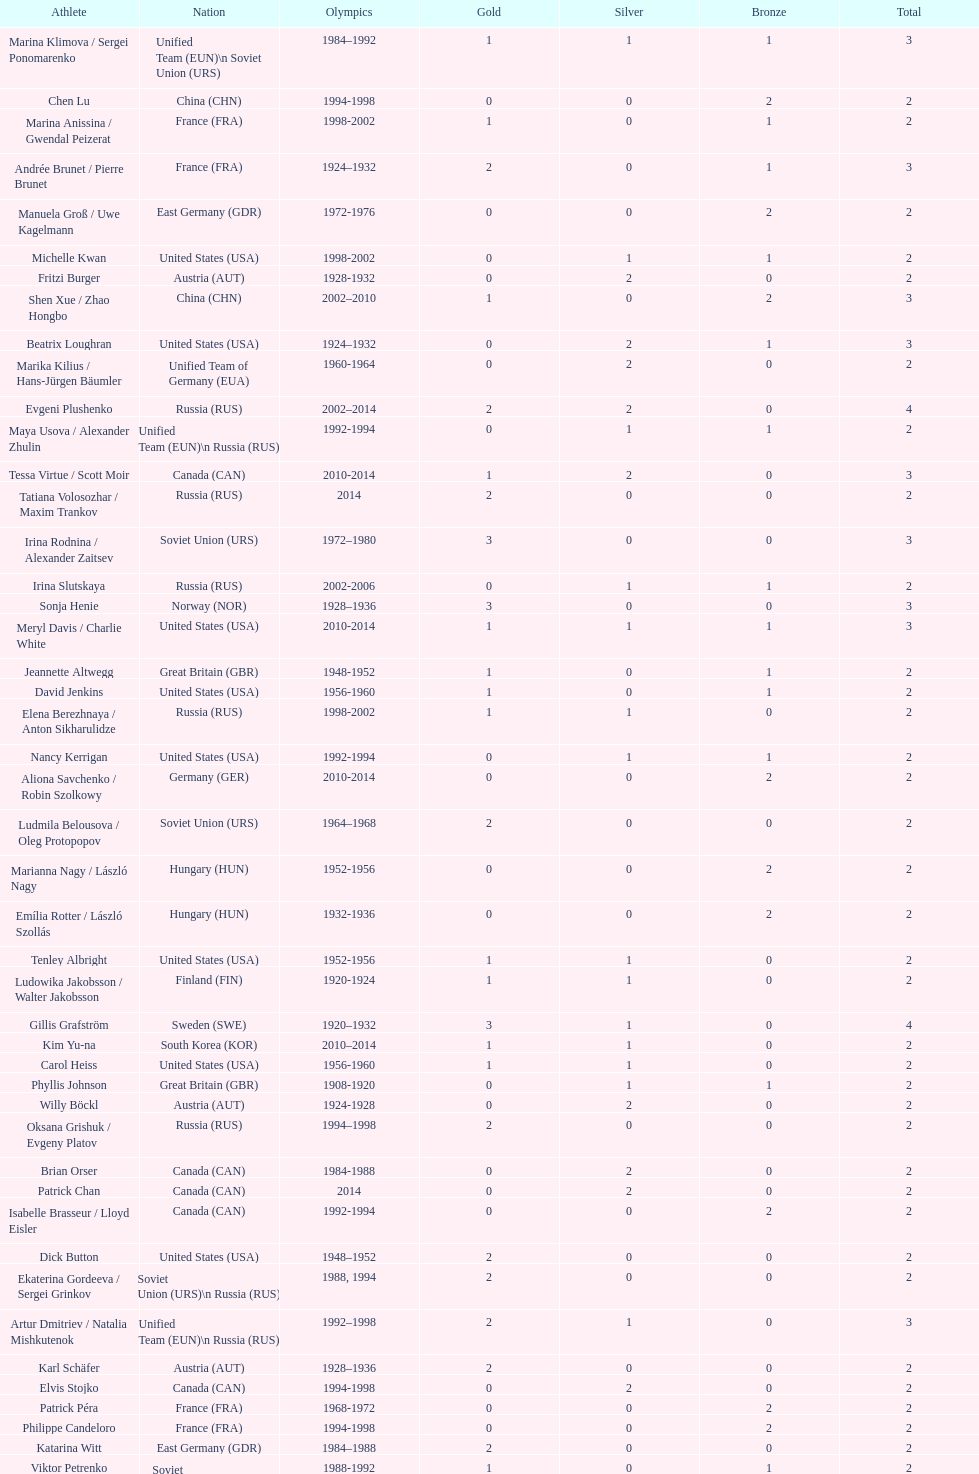How many silver medals did evgeni plushenko get? 2. 